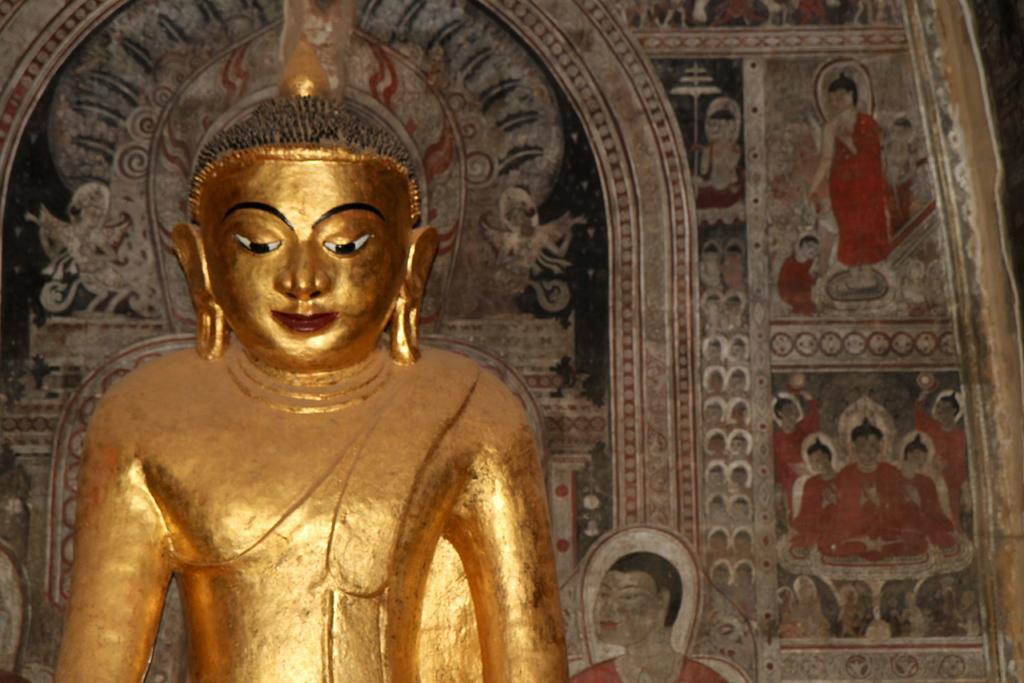Please provide a concise description of this image. In this image of there is a sculpture of Gautama Buddha. Behind the sculpture there is a wall. There are paintings on the wall. 